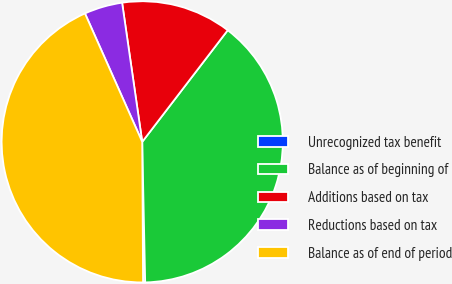Convert chart to OTSL. <chart><loc_0><loc_0><loc_500><loc_500><pie_chart><fcel>Unrecognized tax benefit<fcel>Balance as of beginning of<fcel>Additions based on tax<fcel>Reductions based on tax<fcel>Balance as of end of period<nl><fcel>0.24%<fcel>39.26%<fcel>12.69%<fcel>4.39%<fcel>43.42%<nl></chart> 